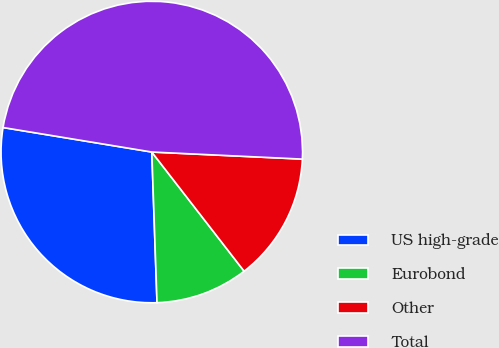<chart> <loc_0><loc_0><loc_500><loc_500><pie_chart><fcel>US high-grade<fcel>Eurobond<fcel>Other<fcel>Total<nl><fcel>28.15%<fcel>9.94%<fcel>13.76%<fcel>48.15%<nl></chart> 